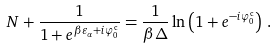Convert formula to latex. <formula><loc_0><loc_0><loc_500><loc_500>N + \frac { 1 } { 1 + e ^ { \beta \varepsilon _ { \alpha } + i \varphi ^ { \text  c}_{0}}} =\frac{1}{\beta\Delta}\ln\left(1+e^{-i \varphi^{\text  c}_{0}}\right)\,.</formula> 